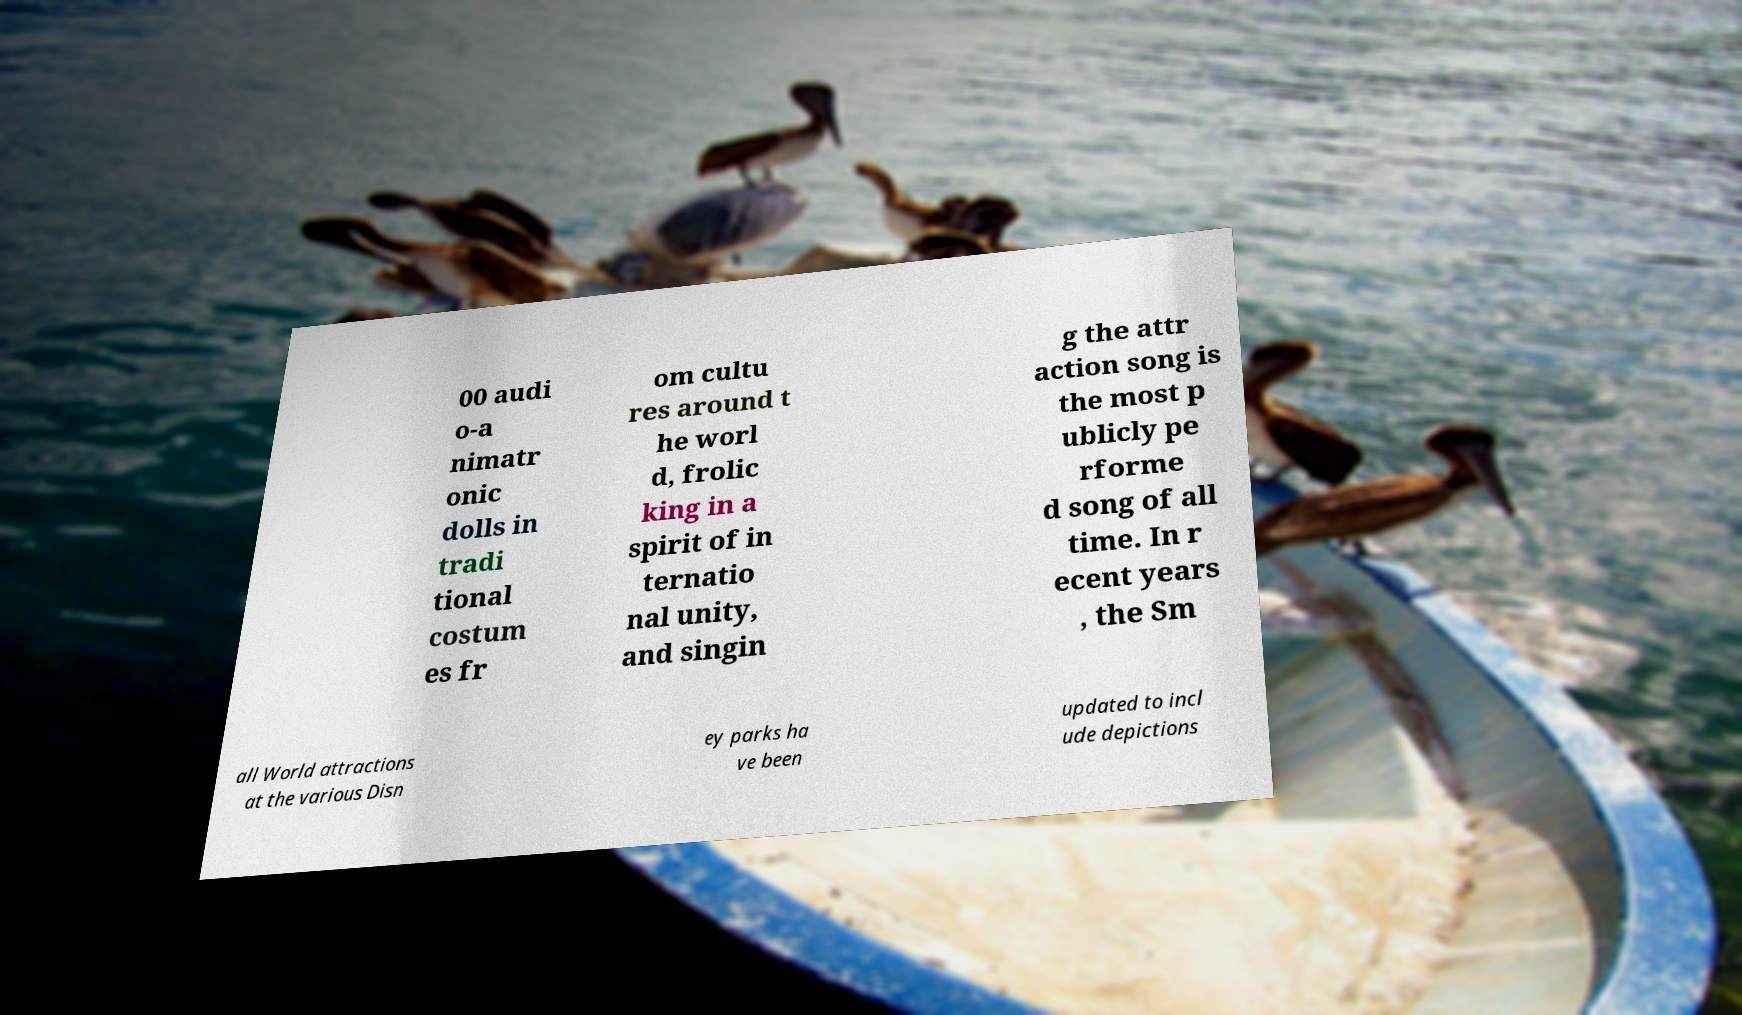What messages or text are displayed in this image? I need them in a readable, typed format. 00 audi o-a nimatr onic dolls in tradi tional costum es fr om cultu res around t he worl d, frolic king in a spirit of in ternatio nal unity, and singin g the attr action song is the most p ublicly pe rforme d song of all time. In r ecent years , the Sm all World attractions at the various Disn ey parks ha ve been updated to incl ude depictions 